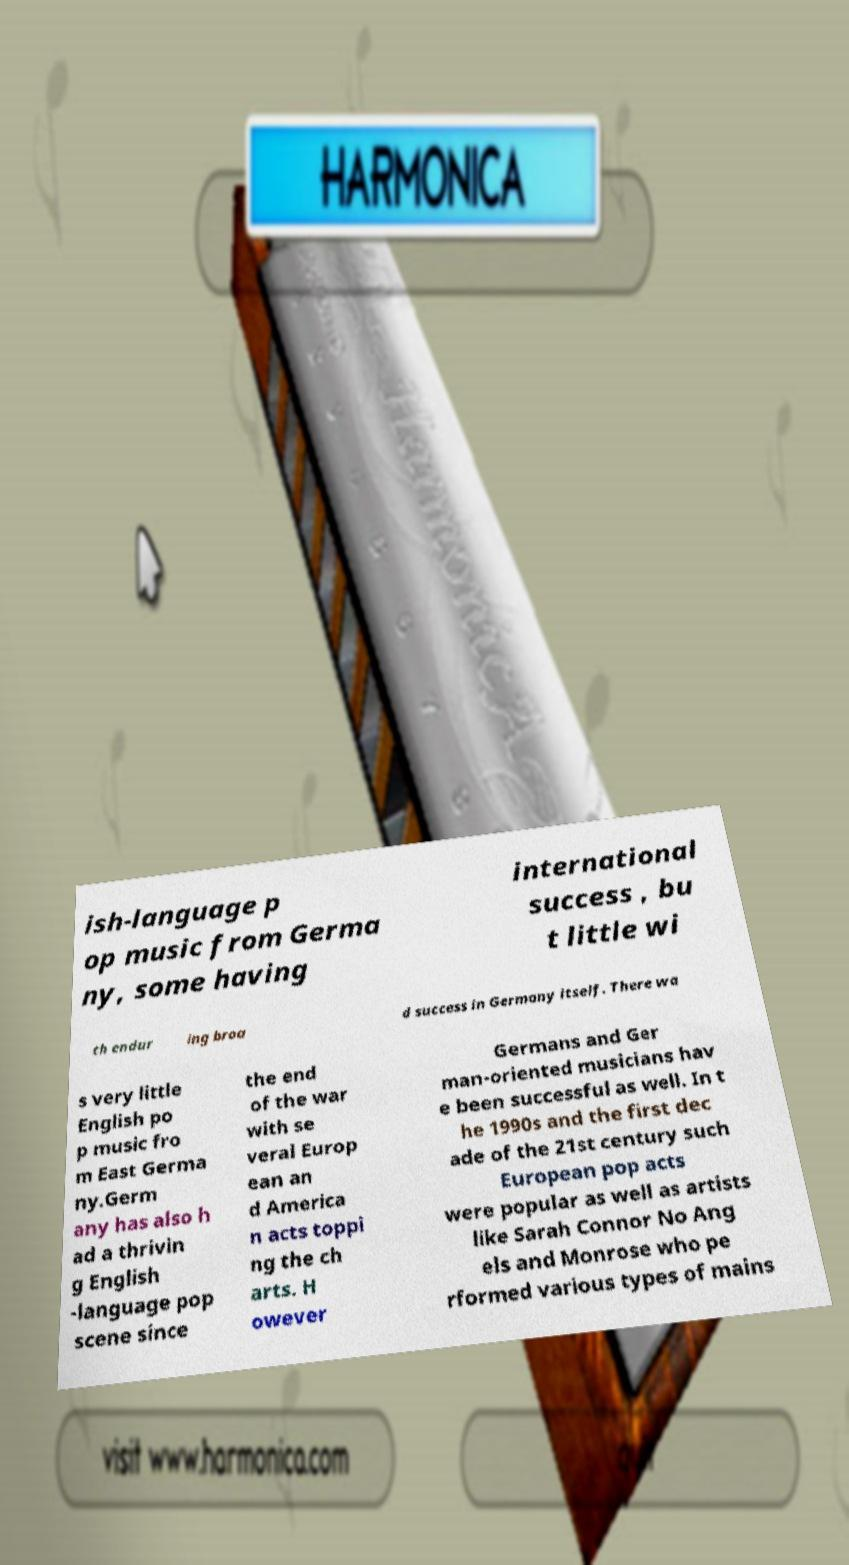I need the written content from this picture converted into text. Can you do that? ish-language p op music from Germa ny, some having international success , bu t little wi th endur ing broa d success in Germany itself. There wa s very little English po p music fro m East Germa ny.Germ any has also h ad a thrivin g English -language pop scene since the end of the war with se veral Europ ean an d America n acts toppi ng the ch arts. H owever Germans and Ger man-oriented musicians hav e been successful as well. In t he 1990s and the first dec ade of the 21st century such European pop acts were popular as well as artists like Sarah Connor No Ang els and Monrose who pe rformed various types of mains 